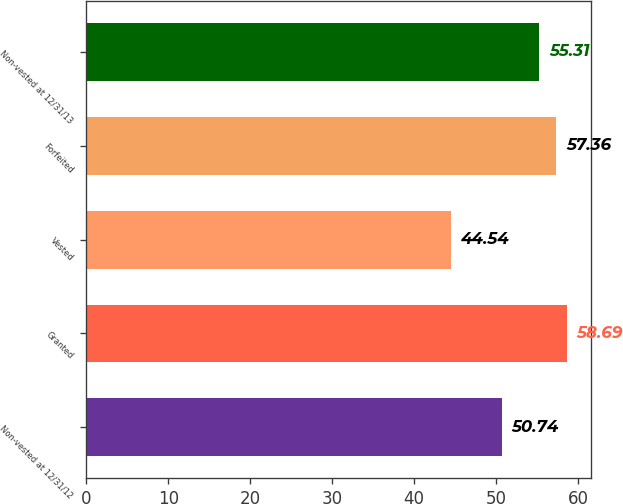Convert chart to OTSL. <chart><loc_0><loc_0><loc_500><loc_500><bar_chart><fcel>Non-vested at 12/31/12<fcel>Granted<fcel>Vested<fcel>Forfeited<fcel>Non-vested at 12/31/13<nl><fcel>50.74<fcel>58.69<fcel>44.54<fcel>57.36<fcel>55.31<nl></chart> 